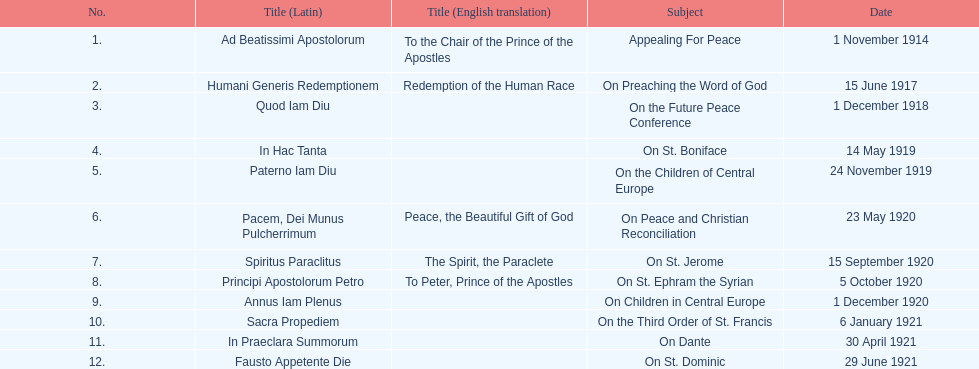What is the first english translation listed on the table? To the Chair of the Prince of the Apostles. 